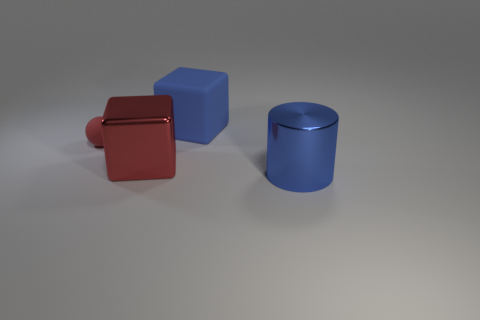Add 4 big metallic cylinders. How many objects exist? 8 Subtract all cylinders. How many objects are left? 3 Add 1 blue metal objects. How many blue metal objects exist? 2 Subtract 0 gray cylinders. How many objects are left? 4 Subtract all big blue matte balls. Subtract all red matte things. How many objects are left? 3 Add 3 red rubber objects. How many red rubber objects are left? 4 